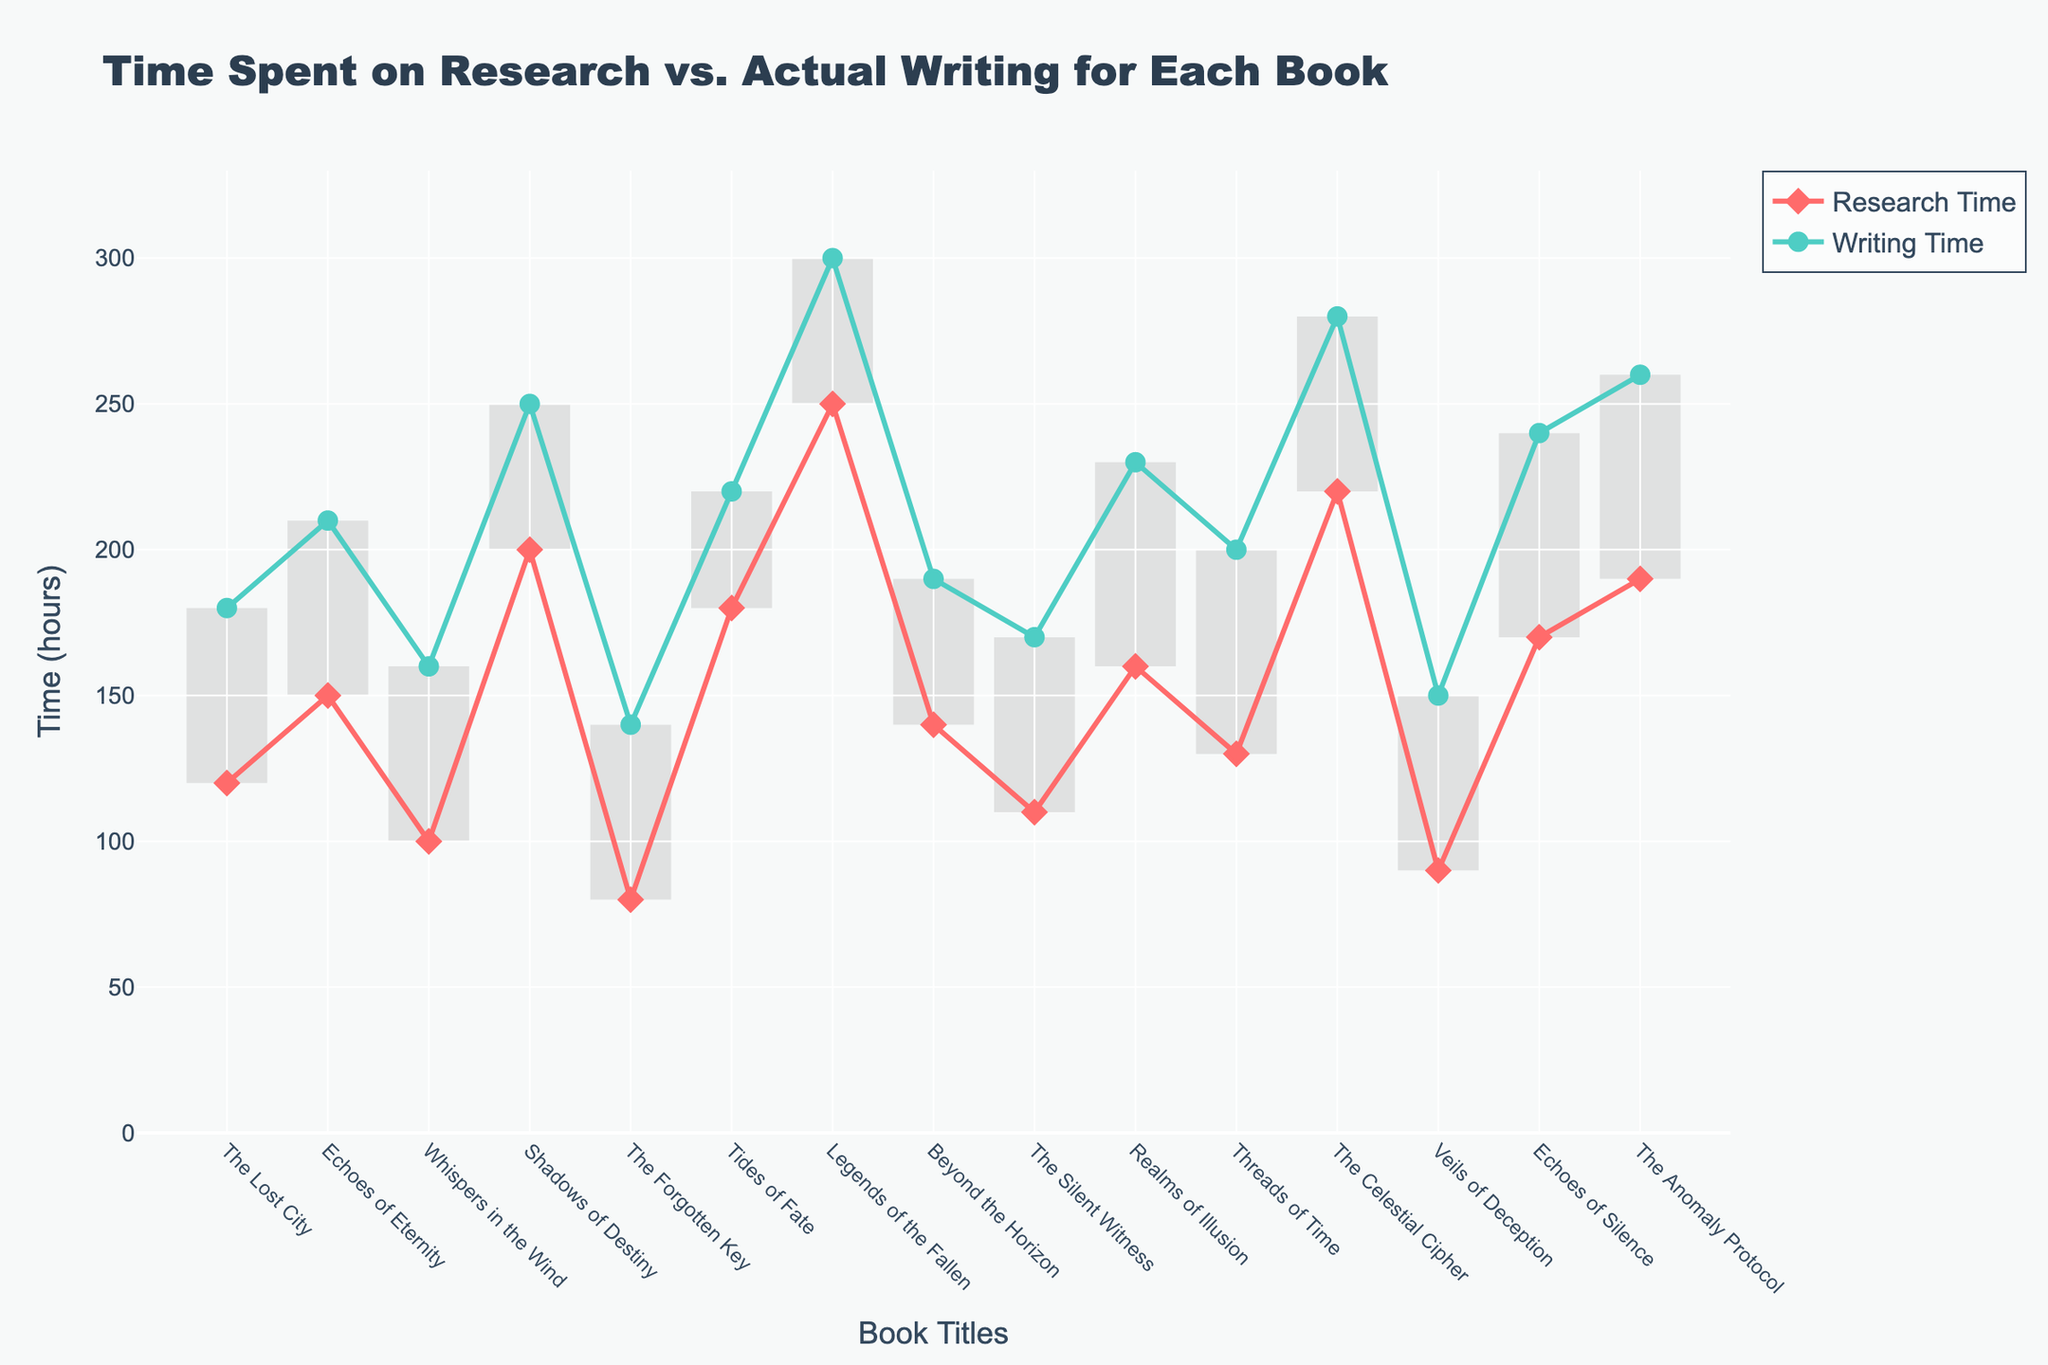What is the total time spent on both research and writing for 'Shadows of Destiny'? First, identify the research time for 'Shadows of Destiny', which is 200 hours. Next, identify the writing time, which is 250 hours. Add these two values together: 200 + 250 = 450 hours.
Answer: 450 hours Which book had the least amount of time spent on research? Examine the research time for each book and identify the minimum value. 'The Forgotten Key' has the least research time, which is 80 hours.
Answer: 'The Forgotten Key' What is the difference in writing time between 'Legends of the Fallen' and 'Tides of Fate'? Identify the writing time for 'Legends of the Fallen' (300 hours) and 'Tides of Fate' (220 hours). Subtract the latter from the former: 300 - 220 = 80 hours.
Answer: 80 hours Which book took more time to write, 'Echoes of Silence' or 'The Celestial Cipher'? Compare the writing times of 'Echoes of Silence' (240 hours) and 'The Celestial Cipher' (280 hours). 'The Celestial Cipher' has a higher value.
Answer: 'The Celestial Cipher' For which book is the difference between research time and writing time the largest? Calculate the difference for each book by subtracting research time from writing time. Identify the maximum difference: ‘Legends of the Fallen’ has the largest difference of 50 hours (300 - 250).
Answer: 'Legends of the Fallen' What is the average writing time for all books? Sum the writing time for each book and divide by the number of books. The total writing time is 3570 hours and there are 15 books, so the average is 3570 / 15 = 238 hours.
Answer: 238 hours How many books took more time on writing than research? Count the books where writing time exceeds research time. By comparing each pair, there are 14 books where writing time is greater.
Answer: 14 Does 'The Lost City' have a higher research or writing time? Compare the research time (120 hours) with the writing time (180 hours) for 'The Lost City'. Writing time is higher.
Answer: Writing time What is the median research time across all books? Arrange the research times in ascending order and identify the middle value. There are 15 values, so the median is the 8th value: 150 hours (after sorting).
Answer: 150 hours Which book took the longest total time for research and writing combined? Compute the sum of research and writing times for each book and identify the maximum total. 'Legends of the Fallen' spent the longest time with 550 hours (250 + 300).
Answer: 'Legends of the Fallen' 